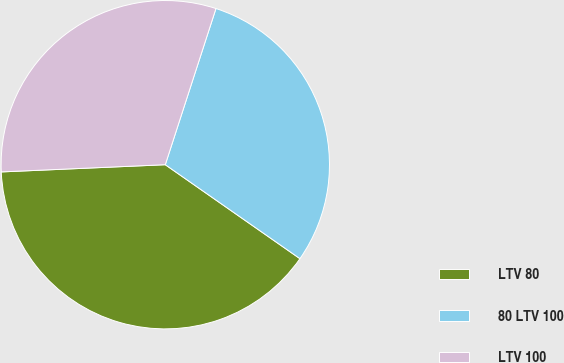Convert chart. <chart><loc_0><loc_0><loc_500><loc_500><pie_chart><fcel>LTV 80<fcel>80 LTV 100<fcel>LTV 100<nl><fcel>39.6%<fcel>29.7%<fcel>30.69%<nl></chart> 